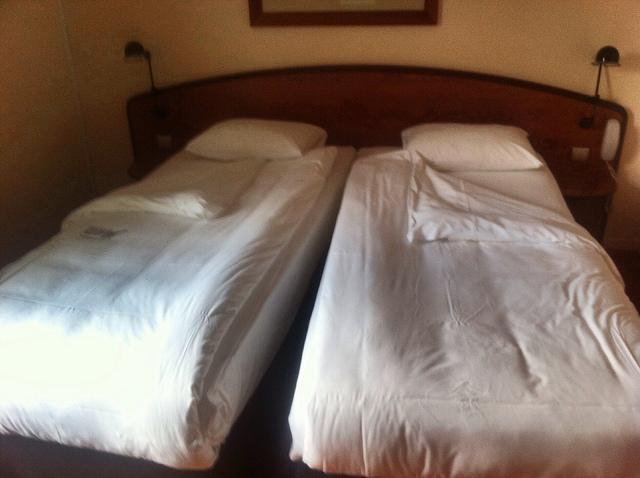How many beds are there?
Give a very brief answer. 2. 